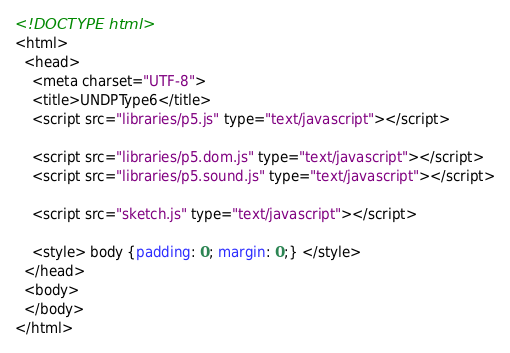<code> <loc_0><loc_0><loc_500><loc_500><_HTML_><!DOCTYPE html>
<html>
  <head>
    <meta charset="UTF-8">
    <title>UNDPType6</title>
    <script src="libraries/p5.js" type="text/javascript"></script>

    <script src="libraries/p5.dom.js" type="text/javascript"></script>
    <script src="libraries/p5.sound.js" type="text/javascript"></script>

    <script src="sketch.js" type="text/javascript"></script>

    <style> body {padding: 0; margin: 0;} </style>
  </head>
  <body>
  </body>
</html>
</code> 